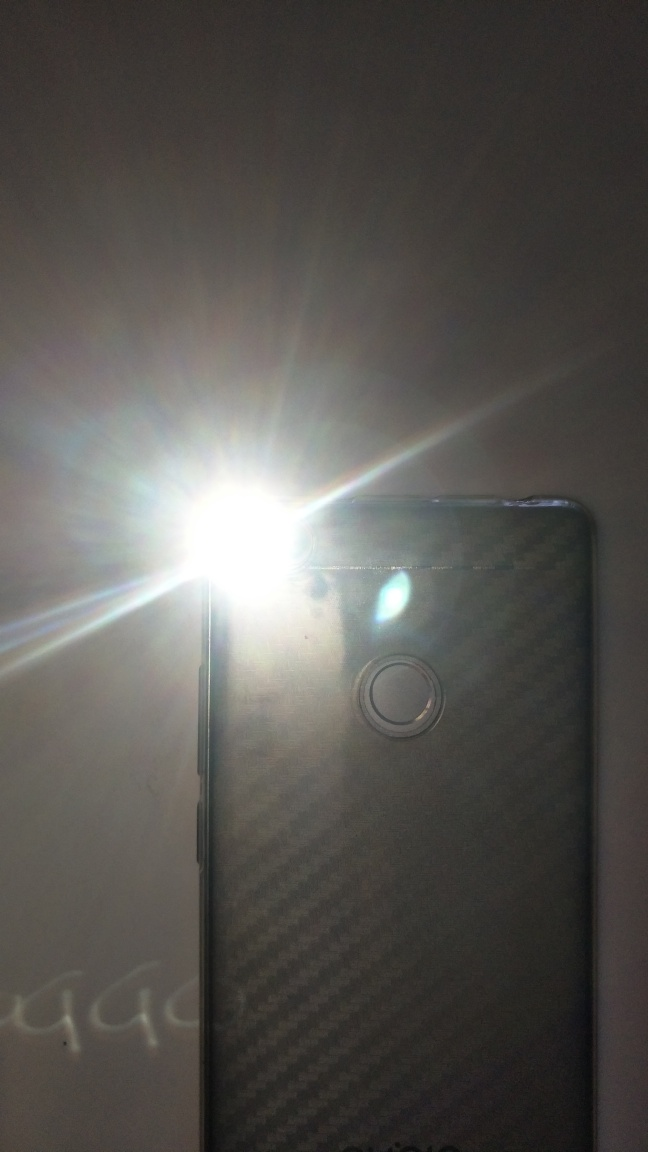Is the main subject a phone and flash?
A. No
B. Yes
Answer with the option's letter from the given choices directly. B. Yes, the main subject in the image is indeed a smartphone with its camera flash activated. The flash is brightly illuminated, suggesting that a photo may have been taken or is about to be taken. 